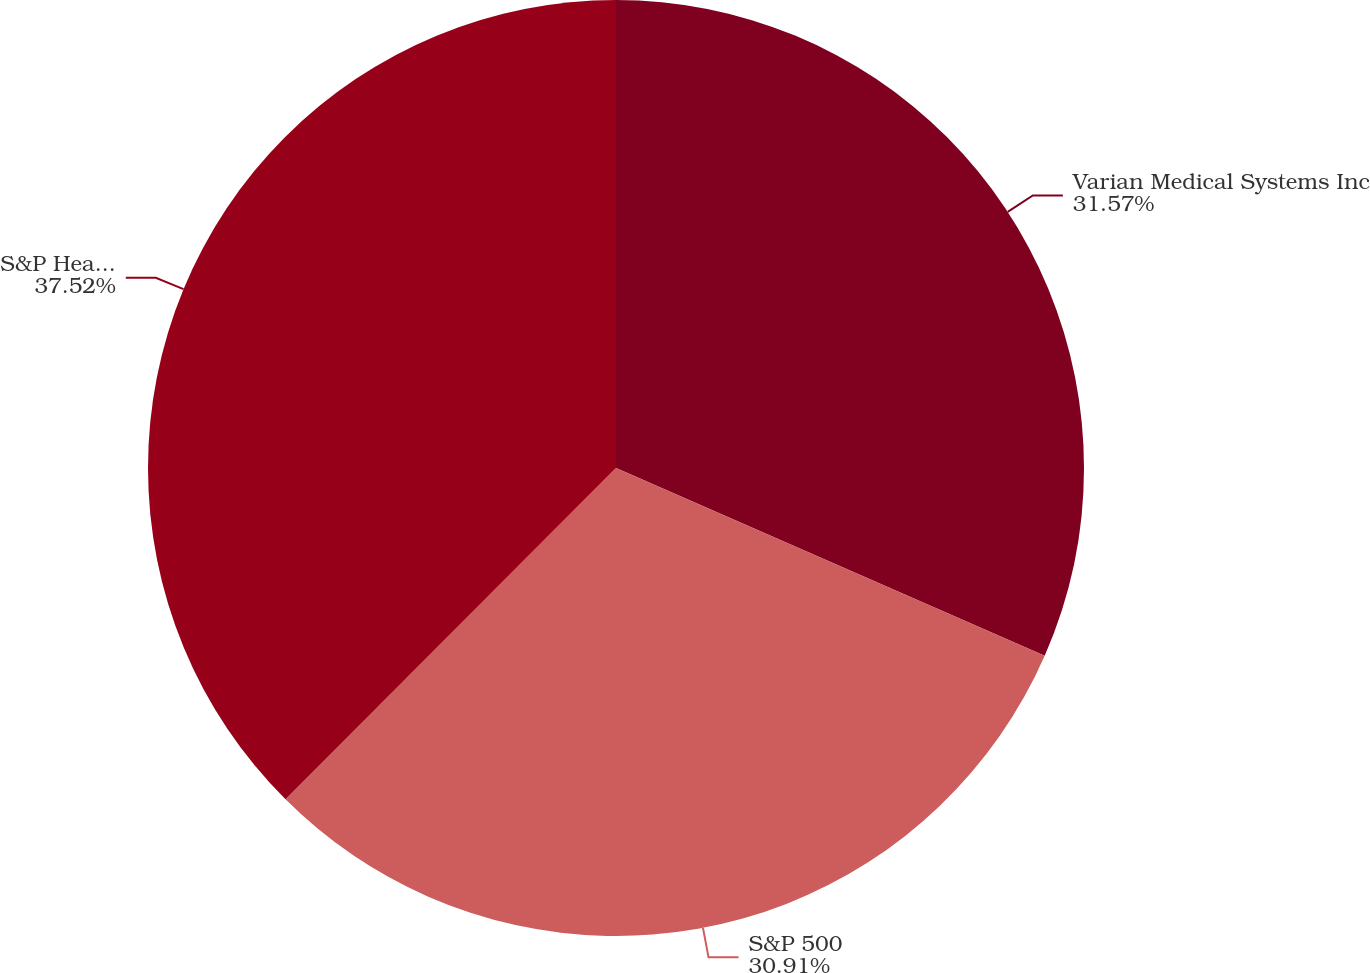Convert chart. <chart><loc_0><loc_0><loc_500><loc_500><pie_chart><fcel>Varian Medical Systems Inc<fcel>S&P 500<fcel>S&P Health Car P e Equipment<nl><fcel>31.57%<fcel>30.91%<fcel>37.52%<nl></chart> 